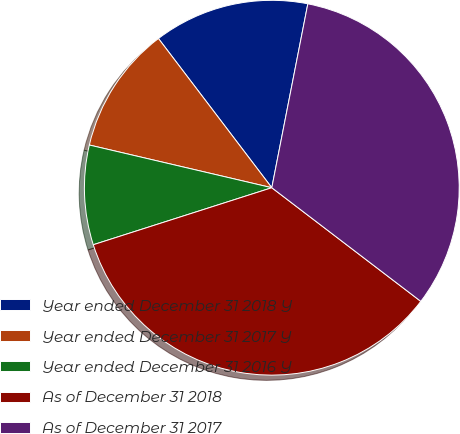Convert chart. <chart><loc_0><loc_0><loc_500><loc_500><pie_chart><fcel>Year ended December 31 2018 Y<fcel>Year ended December 31 2017 Y<fcel>Year ended December 31 2016 Y<fcel>As of December 31 2018<fcel>As of December 31 2017<nl><fcel>13.42%<fcel>11.0%<fcel>8.58%<fcel>34.71%<fcel>32.29%<nl></chart> 